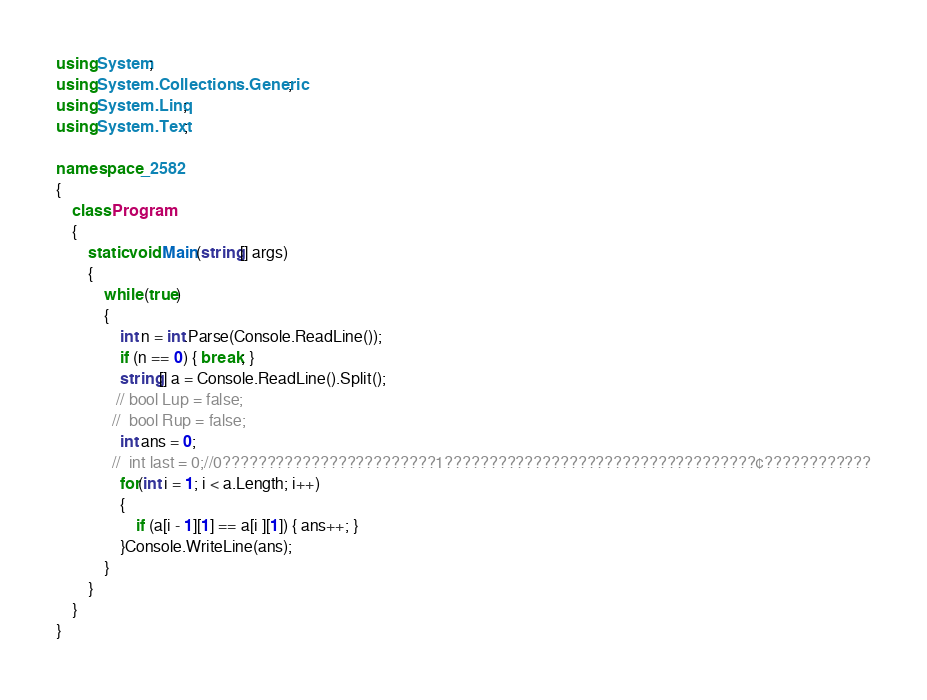<code> <loc_0><loc_0><loc_500><loc_500><_C#_>using System;
using System.Collections.Generic;
using System.Linq;
using System.Text;

namespace _2582
{
    class Program
    {
        static void Main(string[] args)
        {
            while (true)
            {
                int n = int.Parse(Console.ReadLine());
                if (n == 0) { break; }
                string[] a = Console.ReadLine().Split();
               // bool Lup = false;
              //  bool Rup = false;
                int ans = 0;
              //  int last = 0;//0????????????????????????1???????????????????????????????????¢????????????
                for(int i = 1; i < a.Length; i++)
                {
                    if (a[i - 1][1] == a[i ][1]) { ans++; }
                }Console.WriteLine(ans);
            }
        }
    }
}</code> 